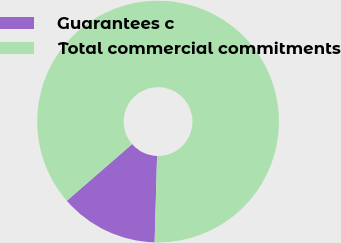Convert chart to OTSL. <chart><loc_0><loc_0><loc_500><loc_500><pie_chart><fcel>Guarantees c<fcel>Total commercial commitments<nl><fcel>13.17%<fcel>86.83%<nl></chart> 